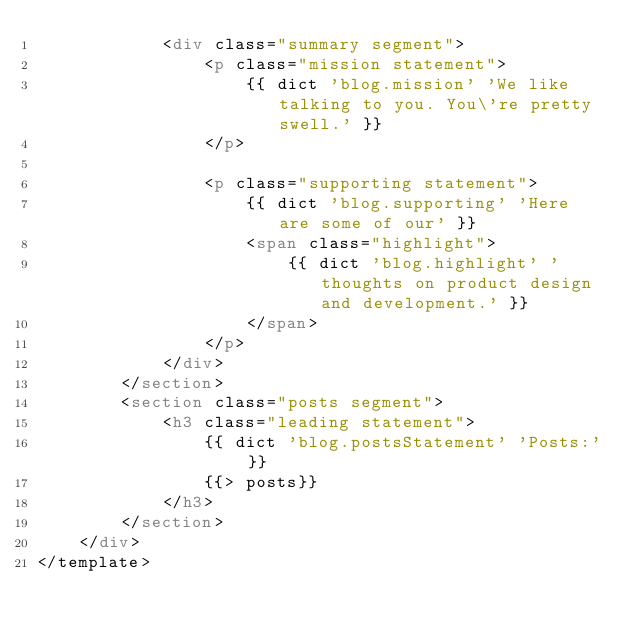<code> <loc_0><loc_0><loc_500><loc_500><_HTML_>            <div class="summary segment">
                <p class="mission statement">
                    {{ dict 'blog.mission' 'We like talking to you. You\'re pretty swell.' }}
                </p>

                <p class="supporting statement">
                    {{ dict 'blog.supporting' 'Here are some of our' }}
                    <span class="highlight">
                        {{ dict 'blog.highlight' 'thoughts on product design and development.' }}
                    </span>
                </p>
            </div>
        </section>
        <section class="posts segment">
            <h3 class="leading statement">
                {{ dict 'blog.postsStatement' 'Posts:' }}
                {{> posts}}
            </h3>
        </section>
    </div>
</template>
</code> 